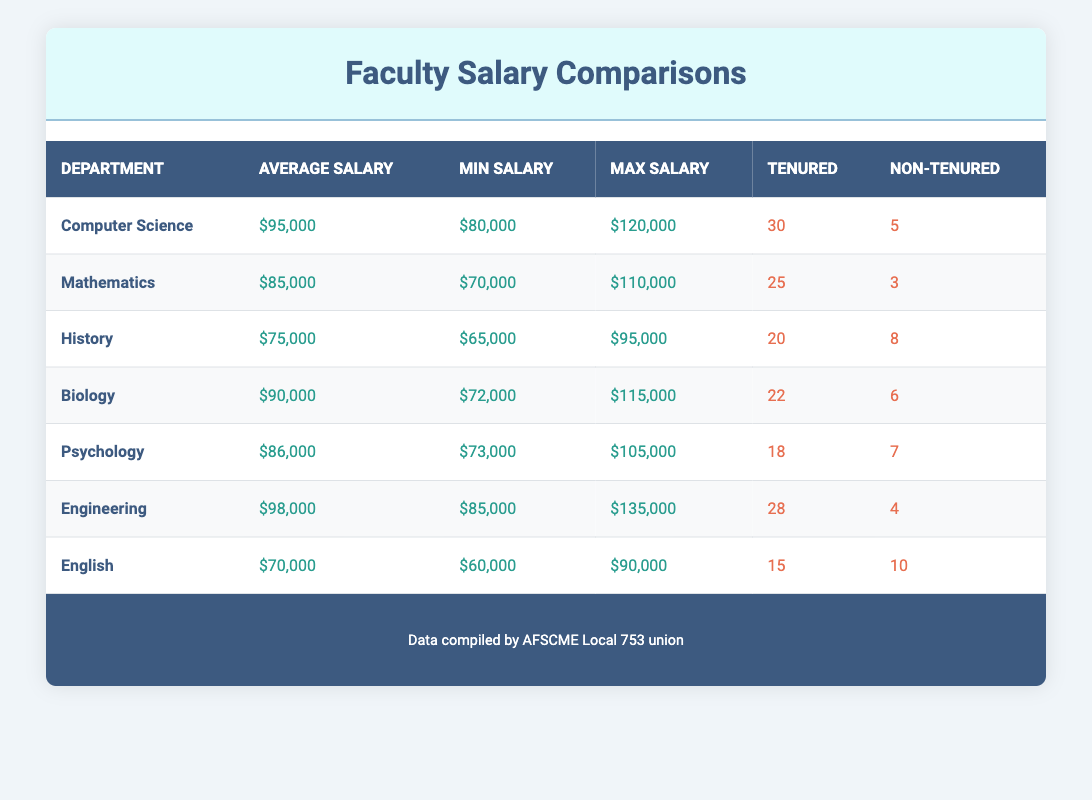What is the average salary of the Engineering department? The table shows that the average salary for the Engineering department is listed as $98,000.
Answer: $98,000 How many non-tenured faculty members are there in the Psychology department? The table provides the number of non-tenured faculty in the Psychology department as 7.
Answer: 7 Which department has the highest maximum salary? By examining the table, the Engineering department has the highest maximum salary listed at $135,000.
Answer: Engineering What is the total number of faculty members (tenured and non-tenured) in the Biology department? The table shows that the tenured count for Biology is 22 and the non-tenured count is 6. Adding these gives a total of 22 + 6 = 28.
Answer: 28 Is the average salary of the History department greater than that of the English department? The average salary for History is $75,000, and for English, it is $70,000. Since $75,000 is greater than $70,000, the statement is true.
Answer: Yes Which department has the lowest average salary, and what is that amount? Reviewing the table, the English department has the lowest average salary of $70,000.
Answer: English, $70,000 If we consider the average salaries of the Computer Science and Mathematics departments combined, what is their average? The average salary for Computer Science is $95,000 and for Mathematics is $85,000. Adding these gives $95,000 + $85,000 = $180,000. Dividing by 2 gives an average of $90,000.
Answer: $90,000 Is the number of tenured faculty in Mathematics greater than the number in History? The table indicates that Mathematics has 25 tenured faculty while History has 20. Since 25 is greater than 20, the answer is true.
Answer: Yes What is the difference between the maximum salary of the Computer Science and the minimum salary of the Psychology department? The maximum salary for Computer Science is $120,000, and the minimum salary for Psychology is $73,000. The difference is $120,000 - $73,000 = $47,000.
Answer: $47,000 